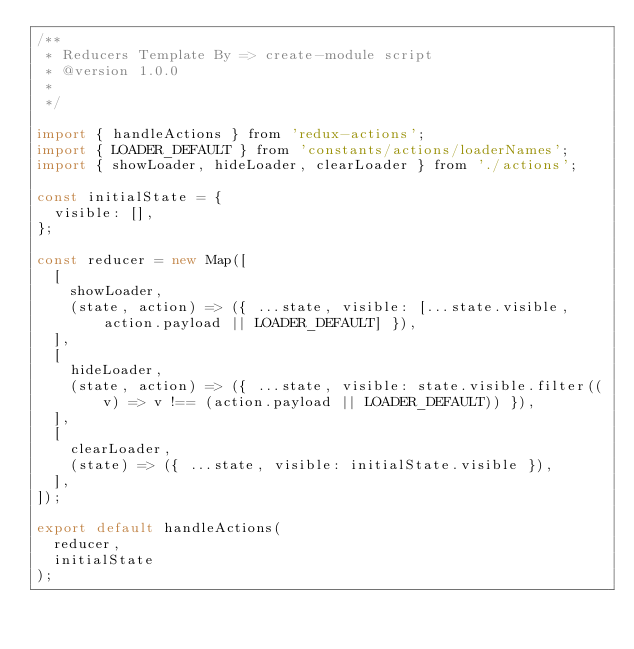Convert code to text. <code><loc_0><loc_0><loc_500><loc_500><_JavaScript_>/**
 * Reducers Template By => create-module script
 * @version 1.0.0
 *
 */

import { handleActions } from 'redux-actions';
import { LOADER_DEFAULT } from 'constants/actions/loaderNames';
import { showLoader, hideLoader, clearLoader } from './actions';

const initialState = {
  visible: [],
};

const reducer = new Map([
  [
    showLoader,
    (state, action) => ({ ...state, visible: [...state.visible, action.payload || LOADER_DEFAULT] }),
  ],
  [
    hideLoader,
    (state, action) => ({ ...state, visible: state.visible.filter((v) => v !== (action.payload || LOADER_DEFAULT)) }),
  ],
  [
    clearLoader,
    (state) => ({ ...state, visible: initialState.visible }),
  ],
]);

export default handleActions(
  reducer,
  initialState
);
</code> 